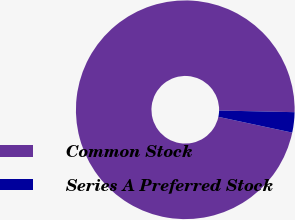Convert chart. <chart><loc_0><loc_0><loc_500><loc_500><pie_chart><fcel>Common Stock<fcel>Series A Preferred Stock<nl><fcel>97.0%<fcel>3.0%<nl></chart> 